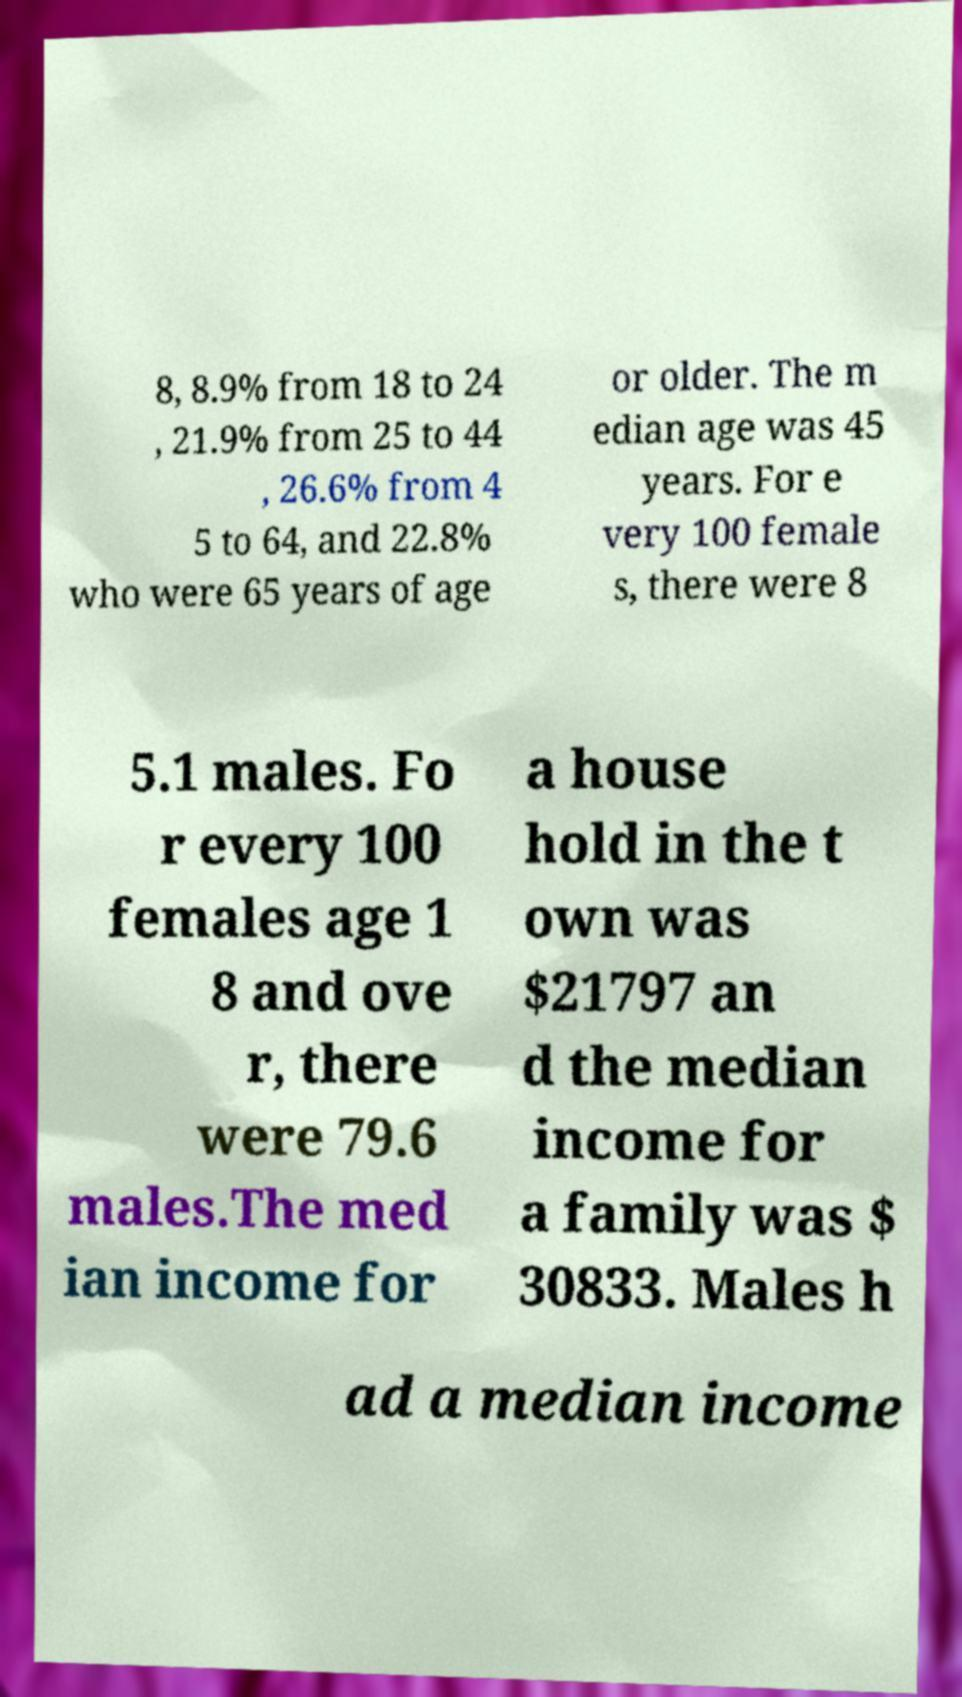Could you assist in decoding the text presented in this image and type it out clearly? 8, 8.9% from 18 to 24 , 21.9% from 25 to 44 , 26.6% from 4 5 to 64, and 22.8% who were 65 years of age or older. The m edian age was 45 years. For e very 100 female s, there were 8 5.1 males. Fo r every 100 females age 1 8 and ove r, there were 79.6 males.The med ian income for a house hold in the t own was $21797 an d the median income for a family was $ 30833. Males h ad a median income 